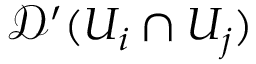<formula> <loc_0><loc_0><loc_500><loc_500>{ \mathcal { D } } ^ { \prime } ( U _ { i } \cap U _ { j } )</formula> 